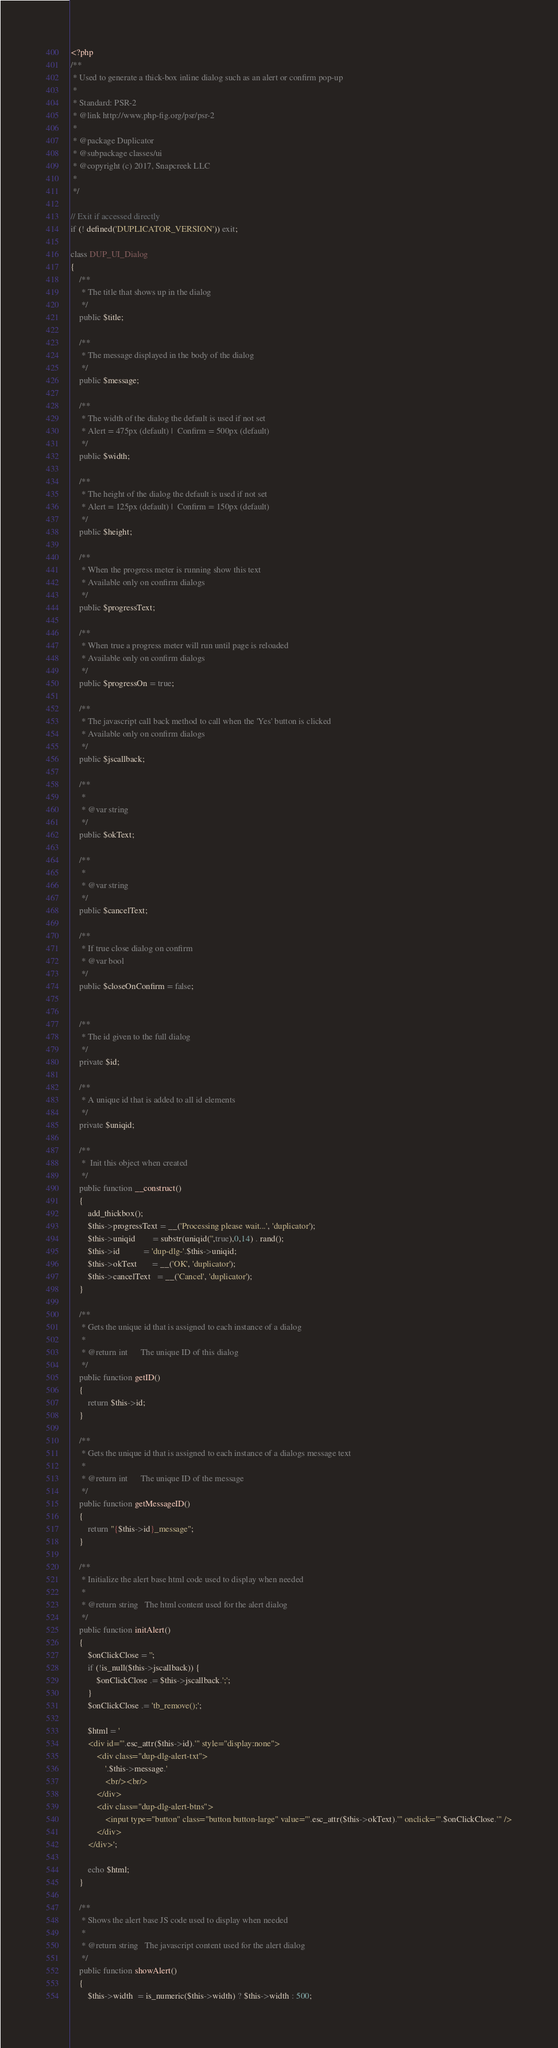Convert code to text. <code><loc_0><loc_0><loc_500><loc_500><_PHP_><?php
/**
 * Used to generate a thick-box inline dialog such as an alert or confirm pop-up
 *
 * Standard: PSR-2
 * @link http://www.php-fig.org/psr/psr-2
 *
 * @package Duplicator
 * @subpackage classes/ui
 * @copyright (c) 2017, Snapcreek LLC
 *
 */

// Exit if accessed directly
if (! defined('DUPLICATOR_VERSION')) exit;

class DUP_UI_Dialog
{
    /**
     * The title that shows up in the dialog
     */
    public $title;

    /**
     * The message displayed in the body of the dialog
     */
    public $message;

    /**
     * The width of the dialog the default is used if not set
     * Alert = 475px (default) |  Confirm = 500px (default)
     */
    public $width;

    /**
     * The height of the dialog the default is used if not set
     * Alert = 125px (default) |  Confirm = 150px (default)
     */
    public $height;

    /**
     * When the progress meter is running show this text
     * Available only on confirm dialogs
     */
    public $progressText;

    /**
     * When true a progress meter will run until page is reloaded
     * Available only on confirm dialogs
     */
    public $progressOn = true;

    /**
     * The javascript call back method to call when the 'Yes' button is clicked
     * Available only on confirm dialogs
     */
    public $jscallback;

    /**
     *
     * @var string
     */
    public $okText;

    /**
     *
     * @var string
     */
    public $cancelText;

    /**
     * If true close dialog on confirm
     * @var bool
     */
    public $closeOnConfirm = false;


    /**
     * The id given to the full dialog
     */
    private $id;

    /**
     * A unique id that is added to all id elements
     */
    private $uniqid;

    /**
     *  Init this object when created
     */
    public function __construct()
    {
        add_thickbox();
        $this->progressText = __('Processing please wait...', 'duplicator');
        $this->uniqid		= substr(uniqid('',true),0,14) . rand();
        $this->id           = 'dup-dlg-'.$this->uniqid;
        $this->okText       = __('OK', 'duplicator');
        $this->cancelText   = __('Cancel', 'duplicator');
    }

    /**
     * Gets the unique id that is assigned to each instance of a dialog
     *
     * @return int      The unique ID of this dialog
     */
    public function getID()
    {
        return $this->id;
    }

    /**
     * Gets the unique id that is assigned to each instance of a dialogs message text
     *
     * @return int      The unique ID of the message
     */
    public function getMessageID()
    {
        return "{$this->id}_message";
    }

    /**
     * Initialize the alert base html code used to display when needed
     *
     * @return string	The html content used for the alert dialog
     */
    public function initAlert()
    {
        $onClickClose = '';
        if (!is_null($this->jscallback)) {
            $onClickClose .= $this->jscallback.';';
        }
        $onClickClose .= 'tb_remove();';

        $html = '
		<div id="'.esc_attr($this->id).'" style="display:none">
			<div class="dup-dlg-alert-txt">
				'.$this->message.'
				<br/><br/>
			</div>
			<div class="dup-dlg-alert-btns">
				<input type="button" class="button button-large" value="'.esc_attr($this->okText).'" onclick="'.$onClickClose.'" />
			</div>
		</div>';

        echo $html;
    }

    /**
     * Shows the alert base JS code used to display when needed
     *
     * @return string	The javascript content used for the alert dialog
     */
    public function showAlert()
    {
        $this->width  = is_numeric($this->width) ? $this->width : 500;</code> 